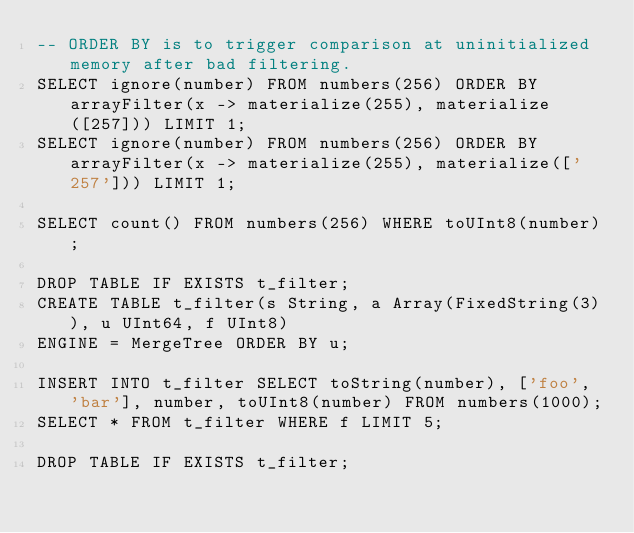<code> <loc_0><loc_0><loc_500><loc_500><_SQL_>-- ORDER BY is to trigger comparison at uninitialized memory after bad filtering.
SELECT ignore(number) FROM numbers(256) ORDER BY arrayFilter(x -> materialize(255), materialize([257])) LIMIT 1;
SELECT ignore(number) FROM numbers(256) ORDER BY arrayFilter(x -> materialize(255), materialize(['257'])) LIMIT 1;

SELECT count() FROM numbers(256) WHERE toUInt8(number);

DROP TABLE IF EXISTS t_filter;
CREATE TABLE t_filter(s String, a Array(FixedString(3)), u UInt64, f UInt8)
ENGINE = MergeTree ORDER BY u;

INSERT INTO t_filter SELECT toString(number), ['foo', 'bar'], number, toUInt8(number) FROM numbers(1000);
SELECT * FROM t_filter WHERE f LIMIT 5;

DROP TABLE IF EXISTS t_filter;
</code> 